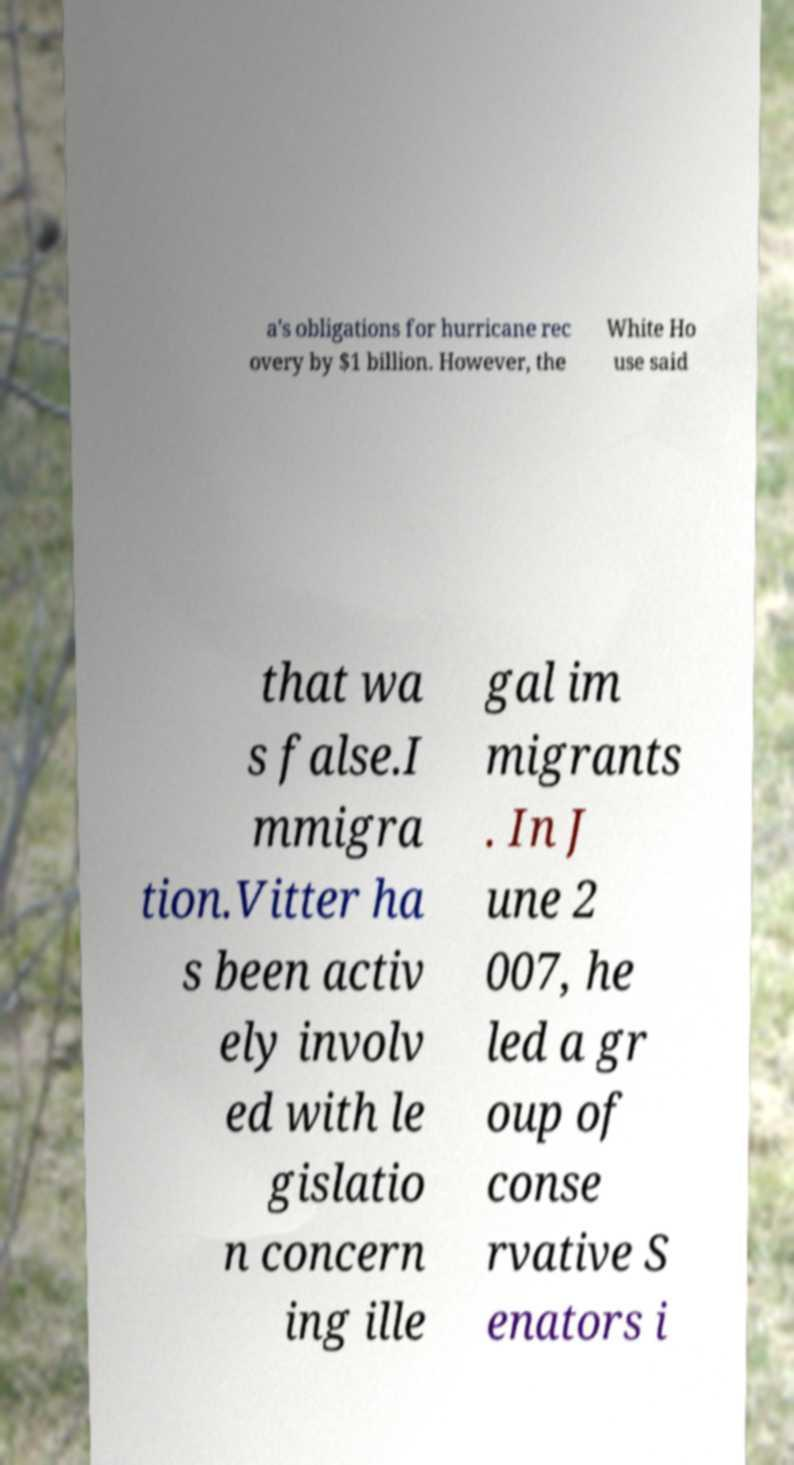Could you extract and type out the text from this image? a's obligations for hurricane rec overy by $1 billion. However, the White Ho use said that wa s false.I mmigra tion.Vitter ha s been activ ely involv ed with le gislatio n concern ing ille gal im migrants . In J une 2 007, he led a gr oup of conse rvative S enators i 